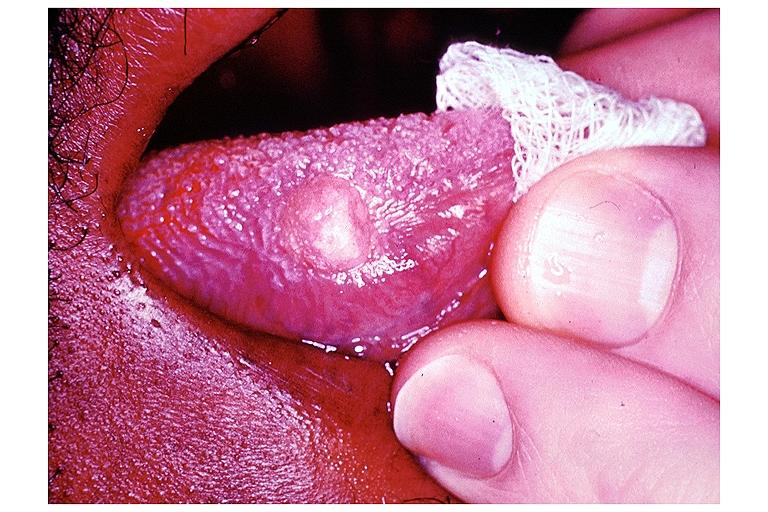what is present?
Answer the question using a single word or phrase. Oral 